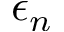Convert formula to latex. <formula><loc_0><loc_0><loc_500><loc_500>\epsilon _ { n }</formula> 